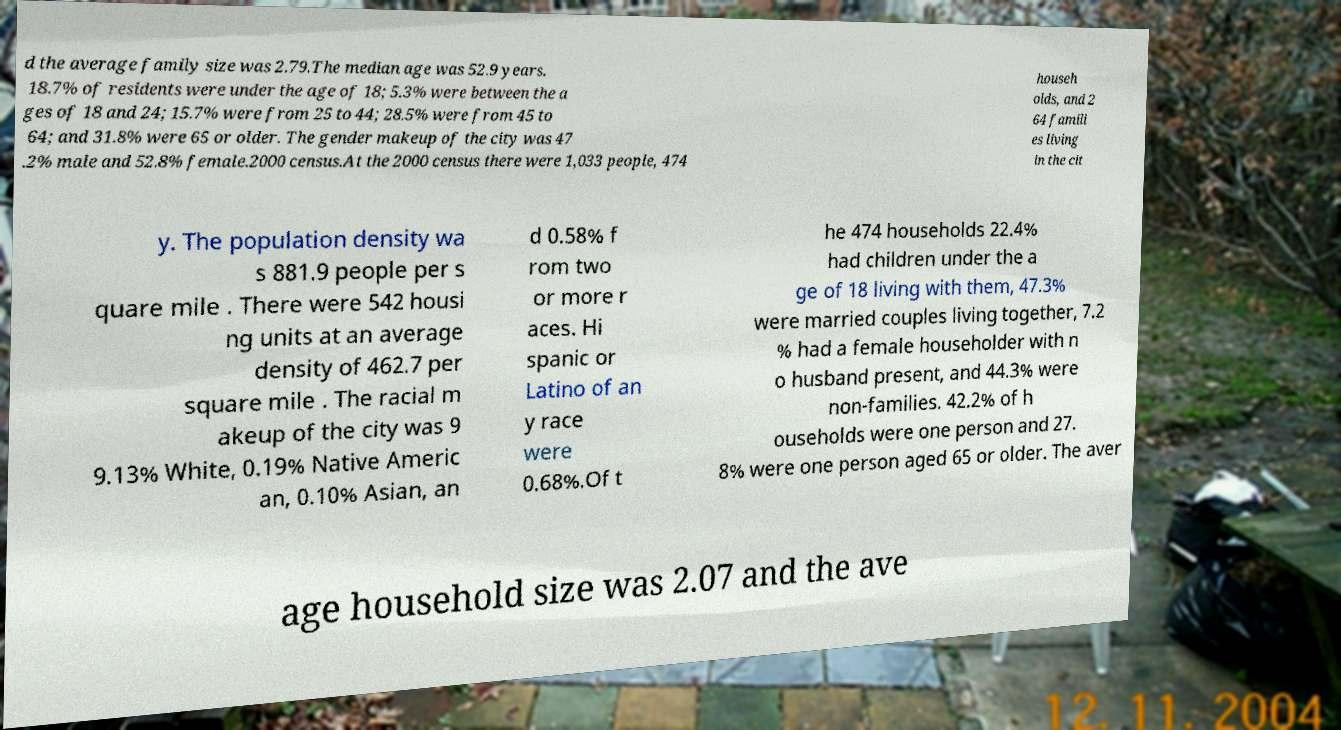Can you read and provide the text displayed in the image?This photo seems to have some interesting text. Can you extract and type it out for me? d the average family size was 2.79.The median age was 52.9 years. 18.7% of residents were under the age of 18; 5.3% were between the a ges of 18 and 24; 15.7% were from 25 to 44; 28.5% were from 45 to 64; and 31.8% were 65 or older. The gender makeup of the city was 47 .2% male and 52.8% female.2000 census.At the 2000 census there were 1,033 people, 474 househ olds, and 2 64 famili es living in the cit y. The population density wa s 881.9 people per s quare mile . There were 542 housi ng units at an average density of 462.7 per square mile . The racial m akeup of the city was 9 9.13% White, 0.19% Native Americ an, 0.10% Asian, an d 0.58% f rom two or more r aces. Hi spanic or Latino of an y race were 0.68%.Of t he 474 households 22.4% had children under the a ge of 18 living with them, 47.3% were married couples living together, 7.2 % had a female householder with n o husband present, and 44.3% were non-families. 42.2% of h ouseholds were one person and 27. 8% were one person aged 65 or older. The aver age household size was 2.07 and the ave 